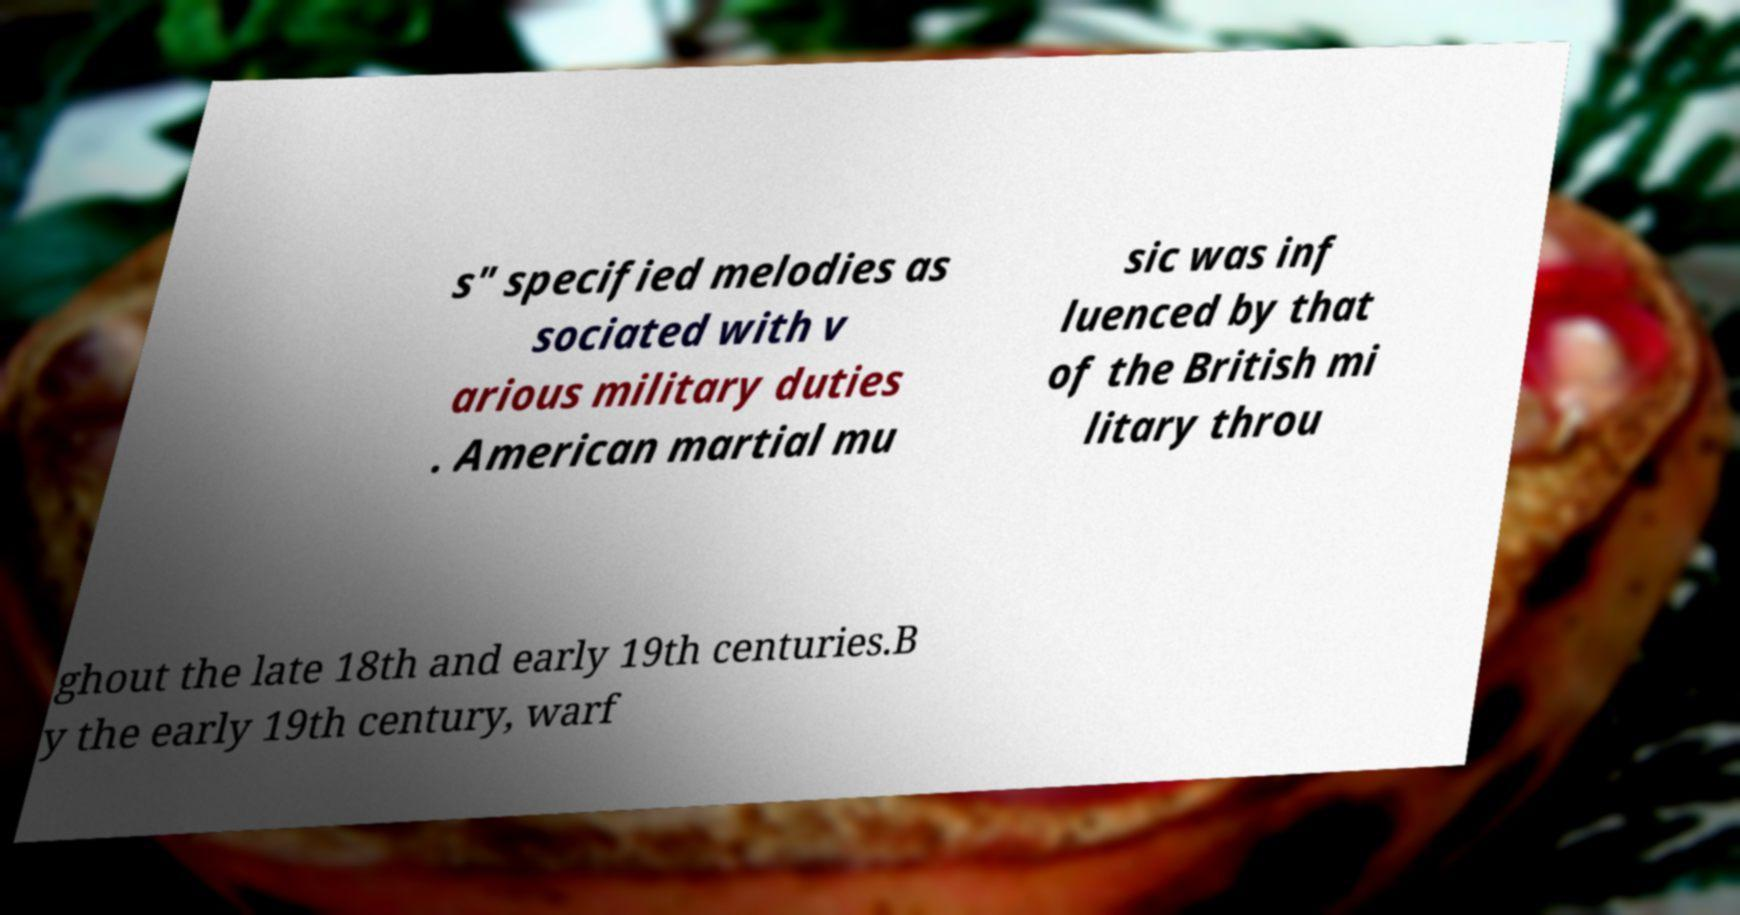Could you extract and type out the text from this image? s" specified melodies as sociated with v arious military duties . American martial mu sic was inf luenced by that of the British mi litary throu ghout the late 18th and early 19th centuries.B y the early 19th century, warf 